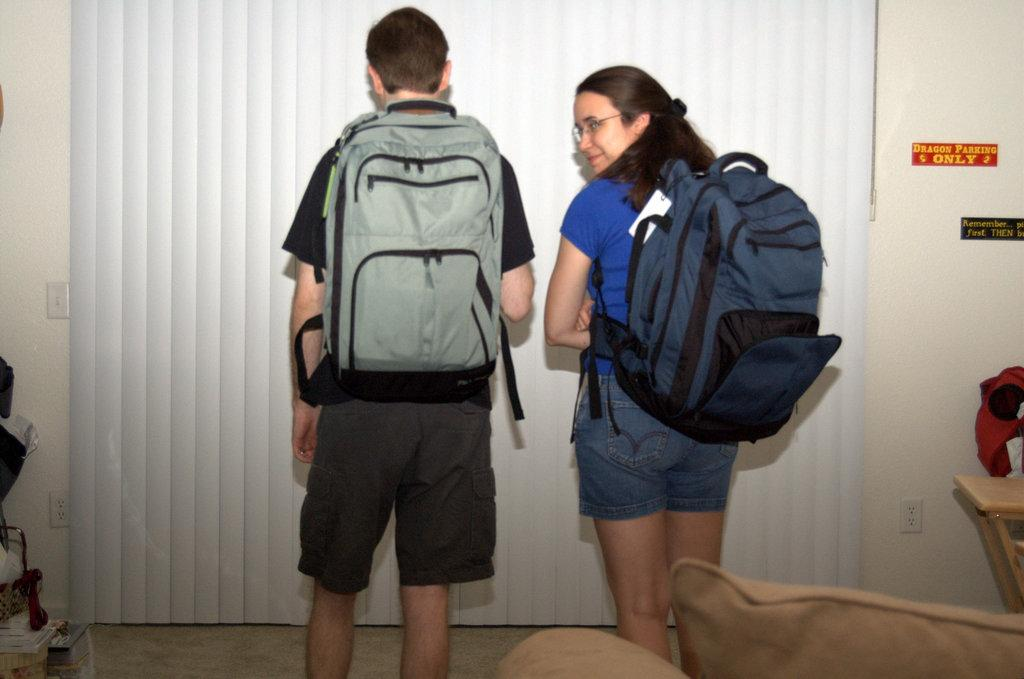Provide a one-sentence caption for the provided image. A boy and girl wearing backpacks next to a sign that says "dragon parking only". 